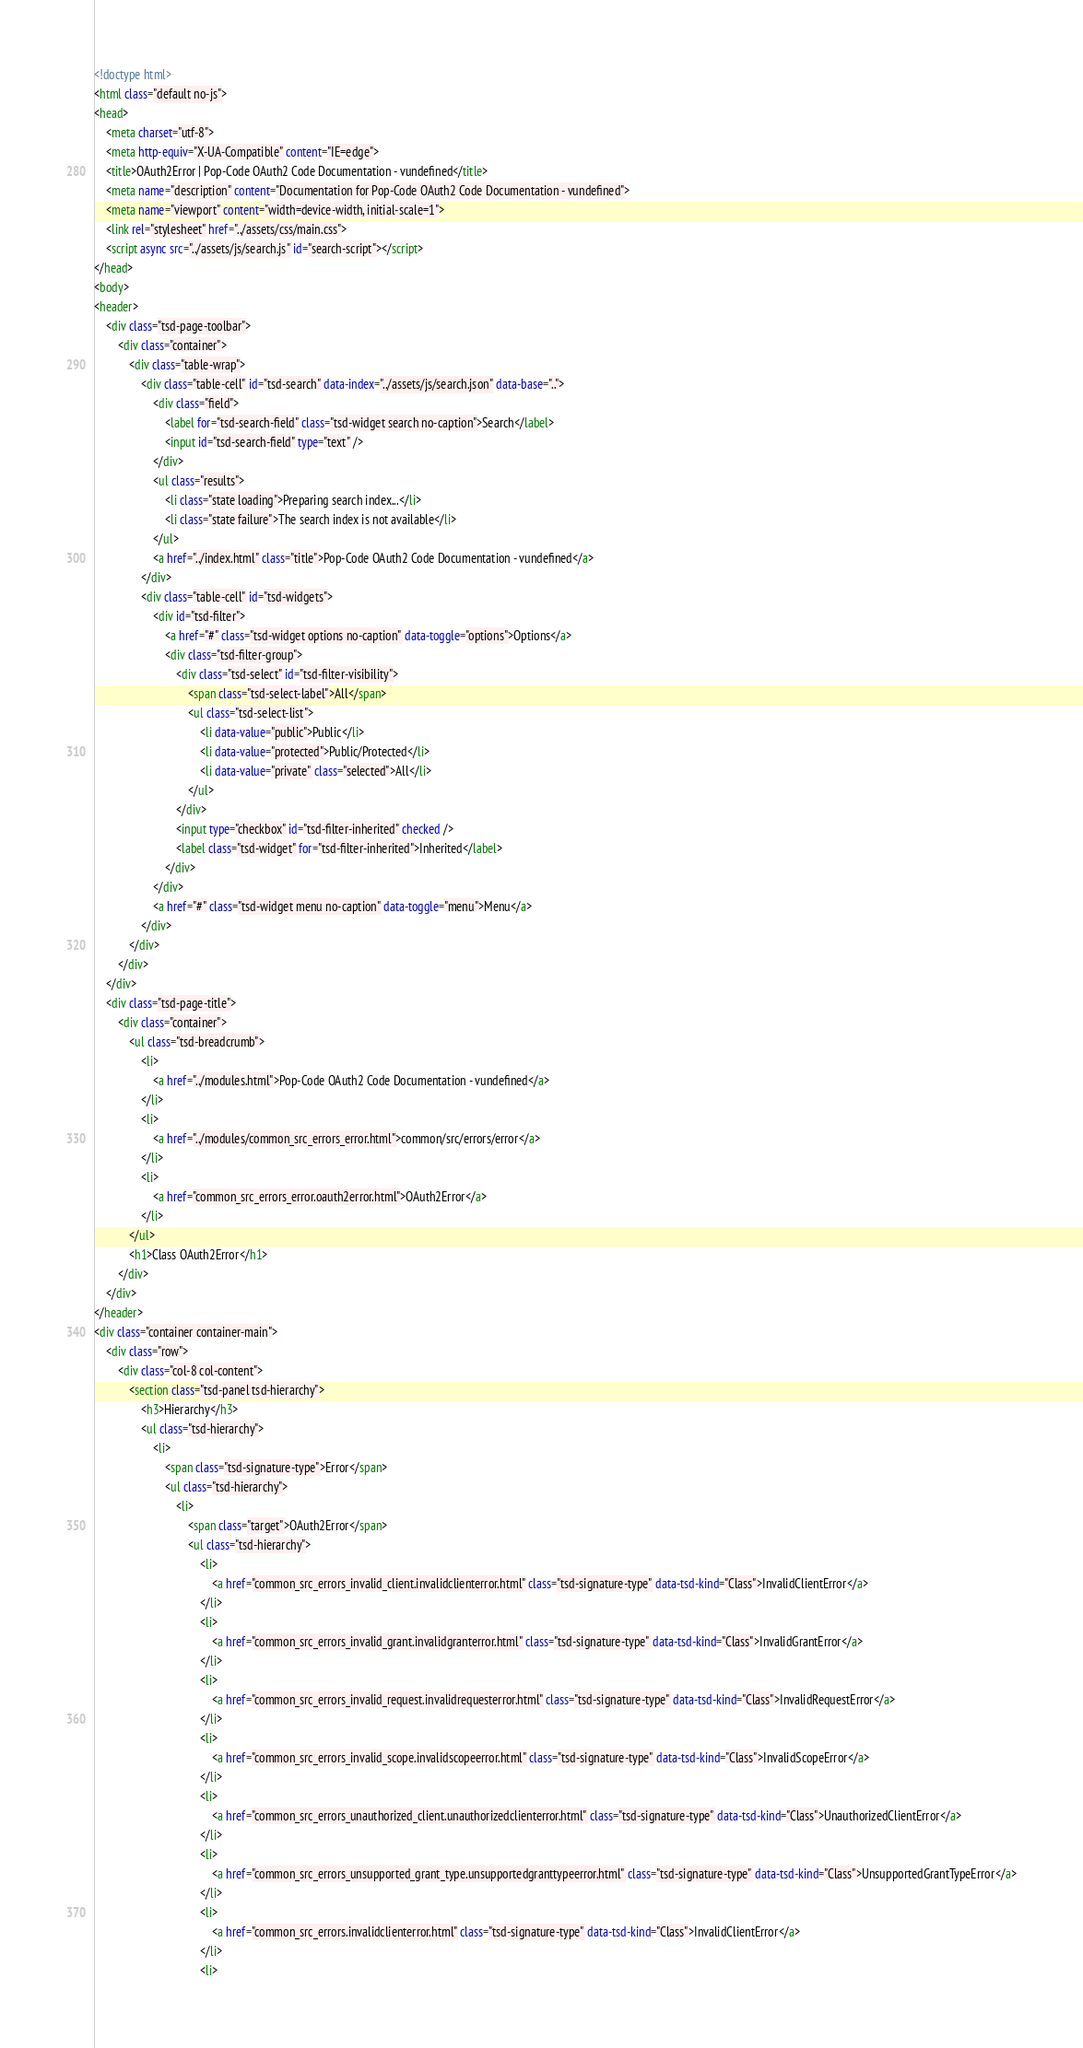Convert code to text. <code><loc_0><loc_0><loc_500><loc_500><_HTML_><!doctype html>
<html class="default no-js">
<head>
	<meta charset="utf-8">
	<meta http-equiv="X-UA-Compatible" content="IE=edge">
	<title>OAuth2Error | Pop-Code OAuth2 Code Documentation - vundefined</title>
	<meta name="description" content="Documentation for Pop-Code OAuth2 Code Documentation - vundefined">
	<meta name="viewport" content="width=device-width, initial-scale=1">
	<link rel="stylesheet" href="../assets/css/main.css">
	<script async src="../assets/js/search.js" id="search-script"></script>
</head>
<body>
<header>
	<div class="tsd-page-toolbar">
		<div class="container">
			<div class="table-wrap">
				<div class="table-cell" id="tsd-search" data-index="../assets/js/search.json" data-base="..">
					<div class="field">
						<label for="tsd-search-field" class="tsd-widget search no-caption">Search</label>
						<input id="tsd-search-field" type="text" />
					</div>
					<ul class="results">
						<li class="state loading">Preparing search index...</li>
						<li class="state failure">The search index is not available</li>
					</ul>
					<a href="../index.html" class="title">Pop-Code OAuth2 Code Documentation - vundefined</a>
				</div>
				<div class="table-cell" id="tsd-widgets">
					<div id="tsd-filter">
						<a href="#" class="tsd-widget options no-caption" data-toggle="options">Options</a>
						<div class="tsd-filter-group">
							<div class="tsd-select" id="tsd-filter-visibility">
								<span class="tsd-select-label">All</span>
								<ul class="tsd-select-list">
									<li data-value="public">Public</li>
									<li data-value="protected">Public/Protected</li>
									<li data-value="private" class="selected">All</li>
								</ul>
							</div>
							<input type="checkbox" id="tsd-filter-inherited" checked />
							<label class="tsd-widget" for="tsd-filter-inherited">Inherited</label>
						</div>
					</div>
					<a href="#" class="tsd-widget menu no-caption" data-toggle="menu">Menu</a>
				</div>
			</div>
		</div>
	</div>
	<div class="tsd-page-title">
		<div class="container">
			<ul class="tsd-breadcrumb">
				<li>
					<a href="../modules.html">Pop-Code OAuth2 Code Documentation - vundefined</a>
				</li>
				<li>
					<a href="../modules/common_src_errors_error.html">common/src/errors/error</a>
				</li>
				<li>
					<a href="common_src_errors_error.oauth2error.html">OAuth2Error</a>
				</li>
			</ul>
			<h1>Class OAuth2Error</h1>
		</div>
	</div>
</header>
<div class="container container-main">
	<div class="row">
		<div class="col-8 col-content">
			<section class="tsd-panel tsd-hierarchy">
				<h3>Hierarchy</h3>
				<ul class="tsd-hierarchy">
					<li>
						<span class="tsd-signature-type">Error</span>
						<ul class="tsd-hierarchy">
							<li>
								<span class="target">OAuth2Error</span>
								<ul class="tsd-hierarchy">
									<li>
										<a href="common_src_errors_invalid_client.invalidclienterror.html" class="tsd-signature-type" data-tsd-kind="Class">InvalidClientError</a>
									</li>
									<li>
										<a href="common_src_errors_invalid_grant.invalidgranterror.html" class="tsd-signature-type" data-tsd-kind="Class">InvalidGrantError</a>
									</li>
									<li>
										<a href="common_src_errors_invalid_request.invalidrequesterror.html" class="tsd-signature-type" data-tsd-kind="Class">InvalidRequestError</a>
									</li>
									<li>
										<a href="common_src_errors_invalid_scope.invalidscopeerror.html" class="tsd-signature-type" data-tsd-kind="Class">InvalidScopeError</a>
									</li>
									<li>
										<a href="common_src_errors_unauthorized_client.unauthorizedclienterror.html" class="tsd-signature-type" data-tsd-kind="Class">UnauthorizedClientError</a>
									</li>
									<li>
										<a href="common_src_errors_unsupported_grant_type.unsupportedgranttypeerror.html" class="tsd-signature-type" data-tsd-kind="Class">UnsupportedGrantTypeError</a>
									</li>
									<li>
										<a href="common_src_errors.invalidclienterror.html" class="tsd-signature-type" data-tsd-kind="Class">InvalidClientError</a>
									</li>
									<li></code> 